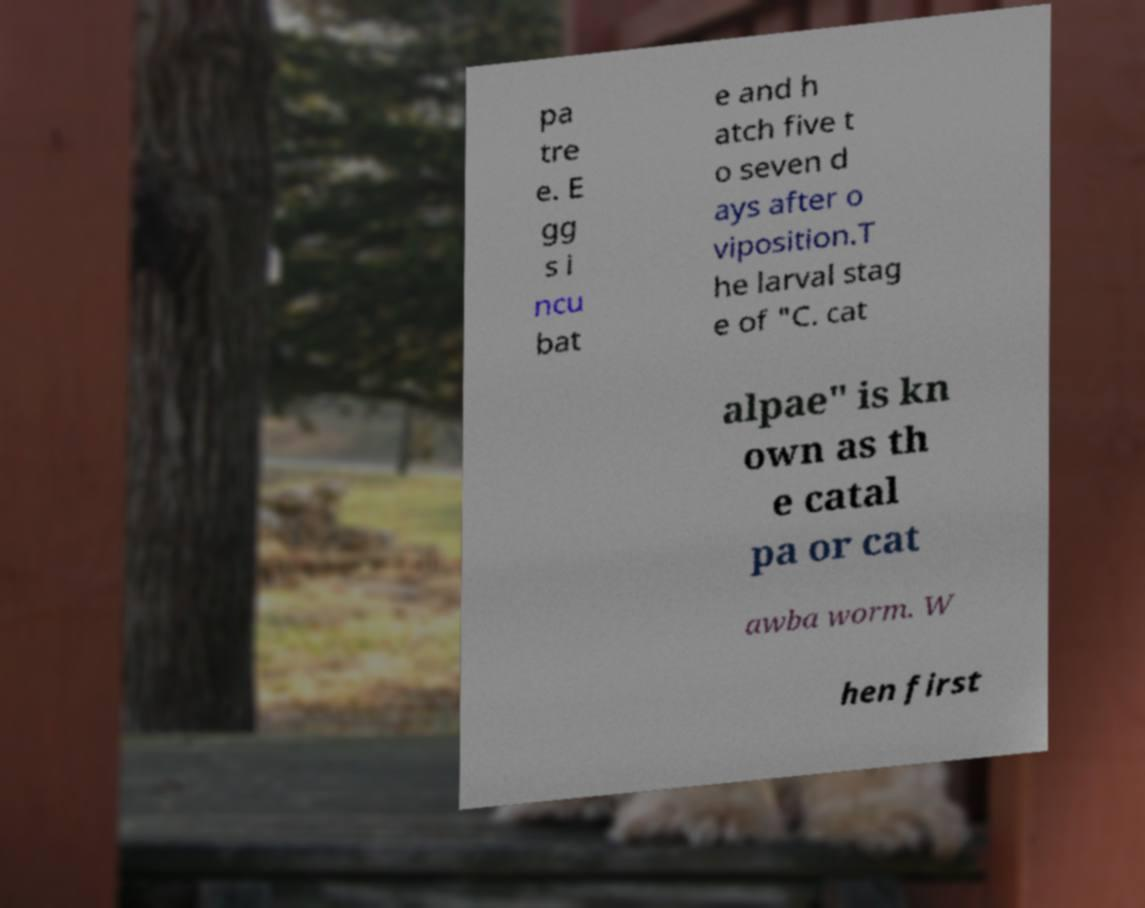There's text embedded in this image that I need extracted. Can you transcribe it verbatim? pa tre e. E gg s i ncu bat e and h atch five t o seven d ays after o viposition.T he larval stag e of "C. cat alpae" is kn own as th e catal pa or cat awba worm. W hen first 